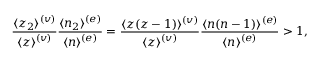<formula> <loc_0><loc_0><loc_500><loc_500>{ \frac { \langle z _ { 2 } \rangle ^ { ( v ) } } { \langle z \rangle ^ { ( v ) } } } { \frac { \langle n _ { 2 } \rangle ^ { ( e ) } } { \langle n \rangle ^ { ( e ) } } } = { \frac { \langle z ( z - 1 ) \rangle ^ { ( v ) } } { \langle z \rangle ^ { ( v ) } } } { \frac { \langle n ( n - 1 ) \rangle ^ { ( e ) } } { \langle n \rangle ^ { ( e ) } } } > 1 ,</formula> 